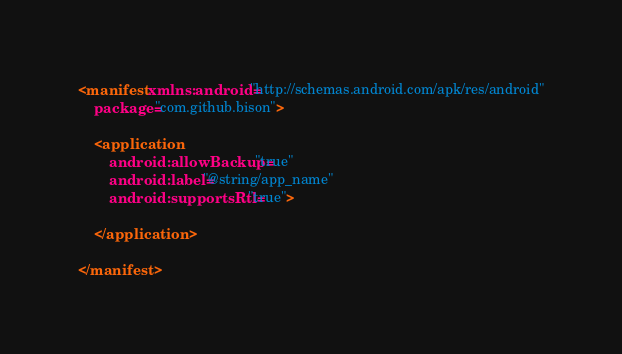Convert code to text. <code><loc_0><loc_0><loc_500><loc_500><_XML_><manifest xmlns:android="http://schemas.android.com/apk/res/android"
    package="com.github.bison">

    <application
        android:allowBackup="true"
        android:label="@string/app_name"
        android:supportsRtl="true">

    </application>

</manifest>
</code> 